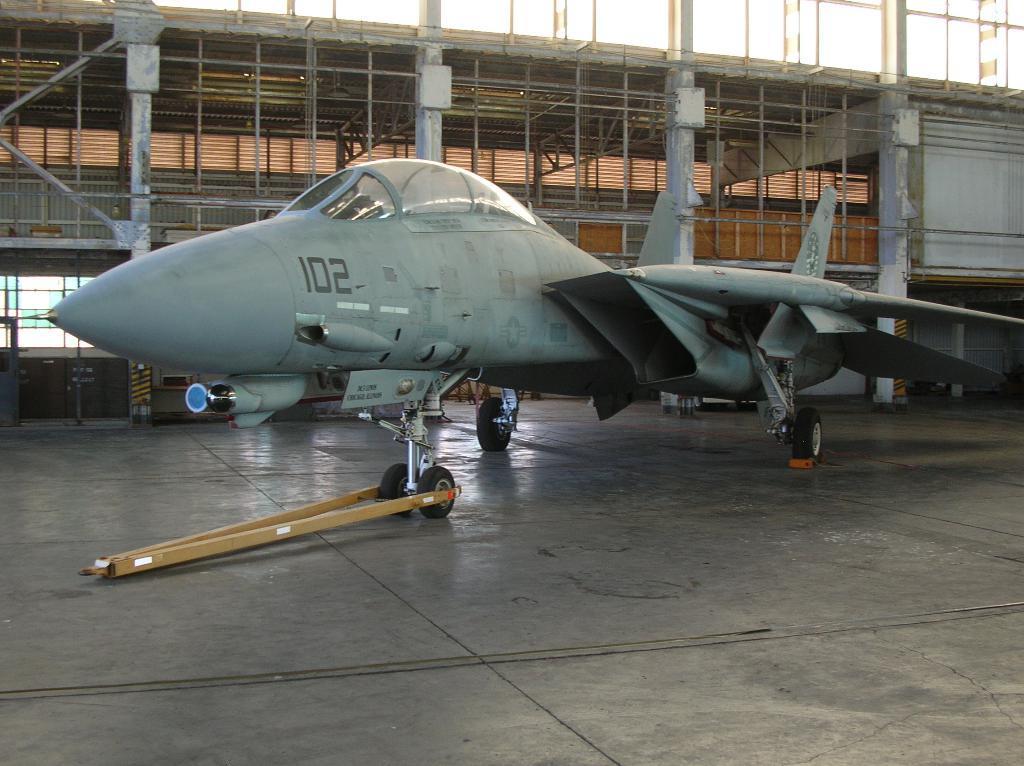Please provide a concise description of this image. In this mage we can see a military jet on the floor, iron grills, poles and sky. 